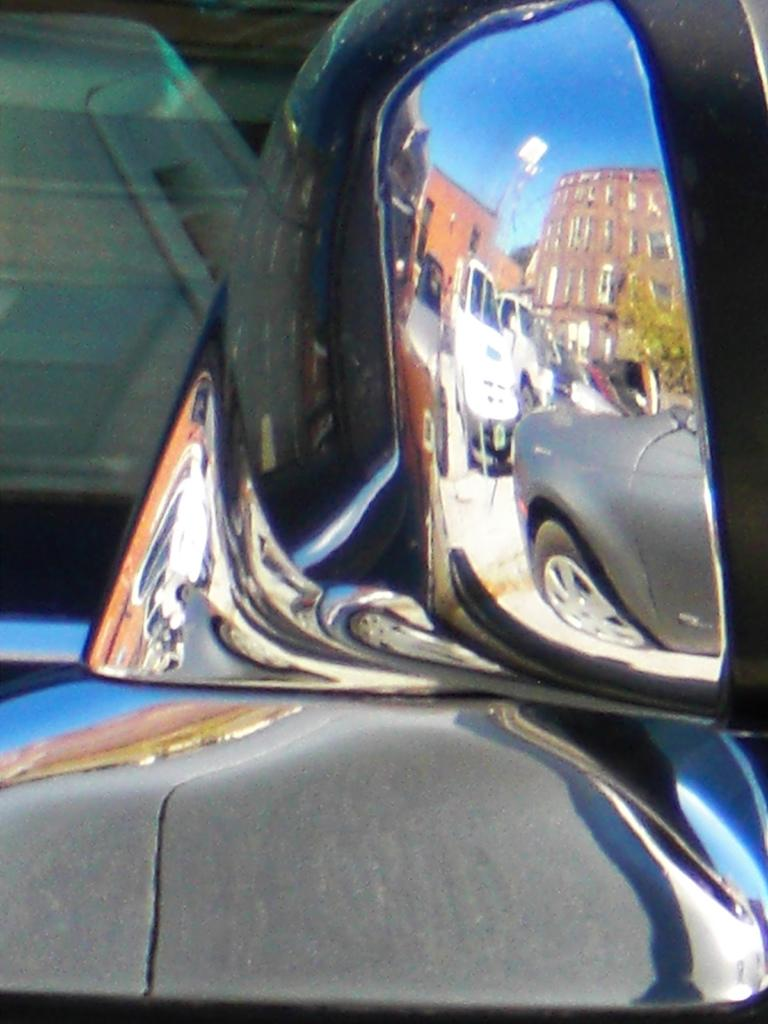What type of object is visible in the image that is commonly found on vehicles? There is a side view mirror in the image. What else can be seen in the image besides the side view mirror? There are vehicles, buildings, trees, and other objects in the image. Can you describe the background of the image? The sky is visible in the background of the image. What type of locket is hanging from the tree in the image? There is no locket present in the image; it features a side view mirror, vehicles, buildings, trees, and other objects, but no locket. Are any people wearing masks in the image? There is no indication of people or masks in the image; it primarily focuses on the side view mirror, vehicles, buildings, trees, and other objects. 